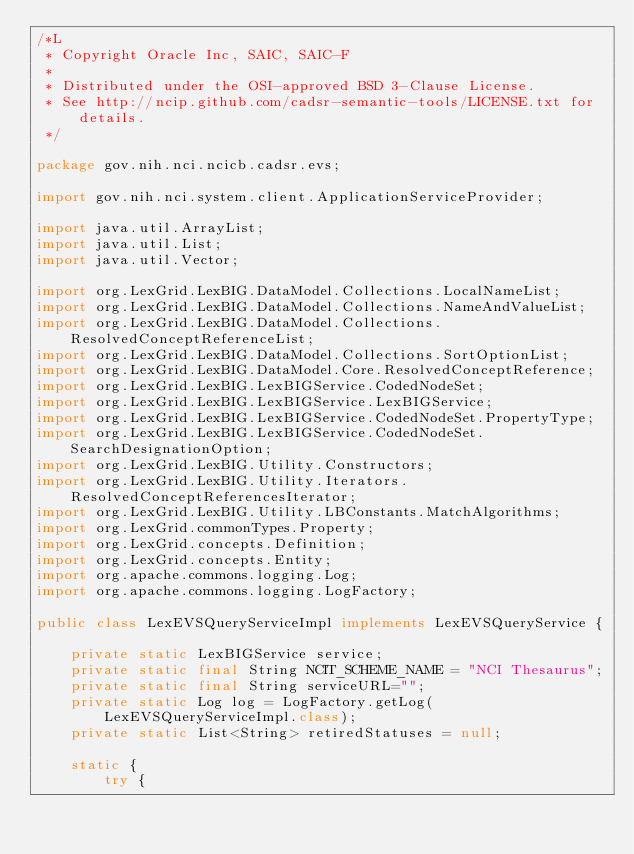Convert code to text. <code><loc_0><loc_0><loc_500><loc_500><_Java_>/*L
 * Copyright Oracle Inc, SAIC, SAIC-F
 *
 * Distributed under the OSI-approved BSD 3-Clause License.
 * See http://ncip.github.com/cadsr-semantic-tools/LICENSE.txt for details.
 */

package gov.nih.nci.ncicb.cadsr.evs;

import gov.nih.nci.system.client.ApplicationServiceProvider;

import java.util.ArrayList;
import java.util.List;
import java.util.Vector;

import org.LexGrid.LexBIG.DataModel.Collections.LocalNameList;
import org.LexGrid.LexBIG.DataModel.Collections.NameAndValueList;
import org.LexGrid.LexBIG.DataModel.Collections.ResolvedConceptReferenceList;
import org.LexGrid.LexBIG.DataModel.Collections.SortOptionList;
import org.LexGrid.LexBIG.DataModel.Core.ResolvedConceptReference;
import org.LexGrid.LexBIG.LexBIGService.CodedNodeSet;
import org.LexGrid.LexBIG.LexBIGService.LexBIGService;
import org.LexGrid.LexBIG.LexBIGService.CodedNodeSet.PropertyType;
import org.LexGrid.LexBIG.LexBIGService.CodedNodeSet.SearchDesignationOption;
import org.LexGrid.LexBIG.Utility.Constructors;
import org.LexGrid.LexBIG.Utility.Iterators.ResolvedConceptReferencesIterator;
import org.LexGrid.LexBIG.Utility.LBConstants.MatchAlgorithms;
import org.LexGrid.commonTypes.Property;
import org.LexGrid.concepts.Definition;
import org.LexGrid.concepts.Entity;
import org.apache.commons.logging.Log;
import org.apache.commons.logging.LogFactory;

public class LexEVSQueryServiceImpl implements LexEVSQueryService {

	private static LexBIGService service;
	private static final String NCIT_SCHEME_NAME = "NCI Thesaurus";
	private static final String serviceURL="";
	private static Log log = LogFactory.getLog(LexEVSQueryServiceImpl.class);
	private static List<String> retiredStatuses = null;
	
	static {
		try {</code> 